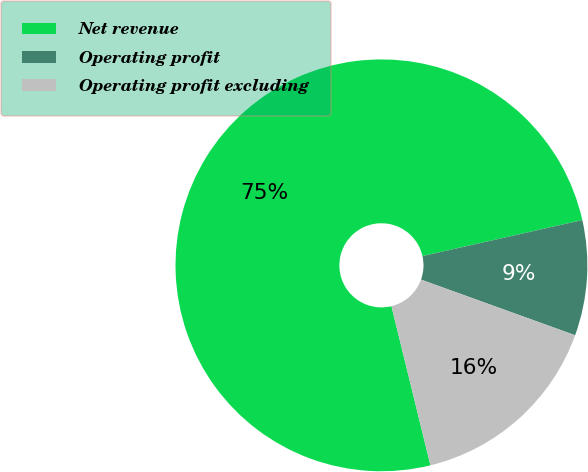Convert chart to OTSL. <chart><loc_0><loc_0><loc_500><loc_500><pie_chart><fcel>Net revenue<fcel>Operating profit<fcel>Operating profit excluding<nl><fcel>75.3%<fcel>9.04%<fcel>15.66%<nl></chart> 